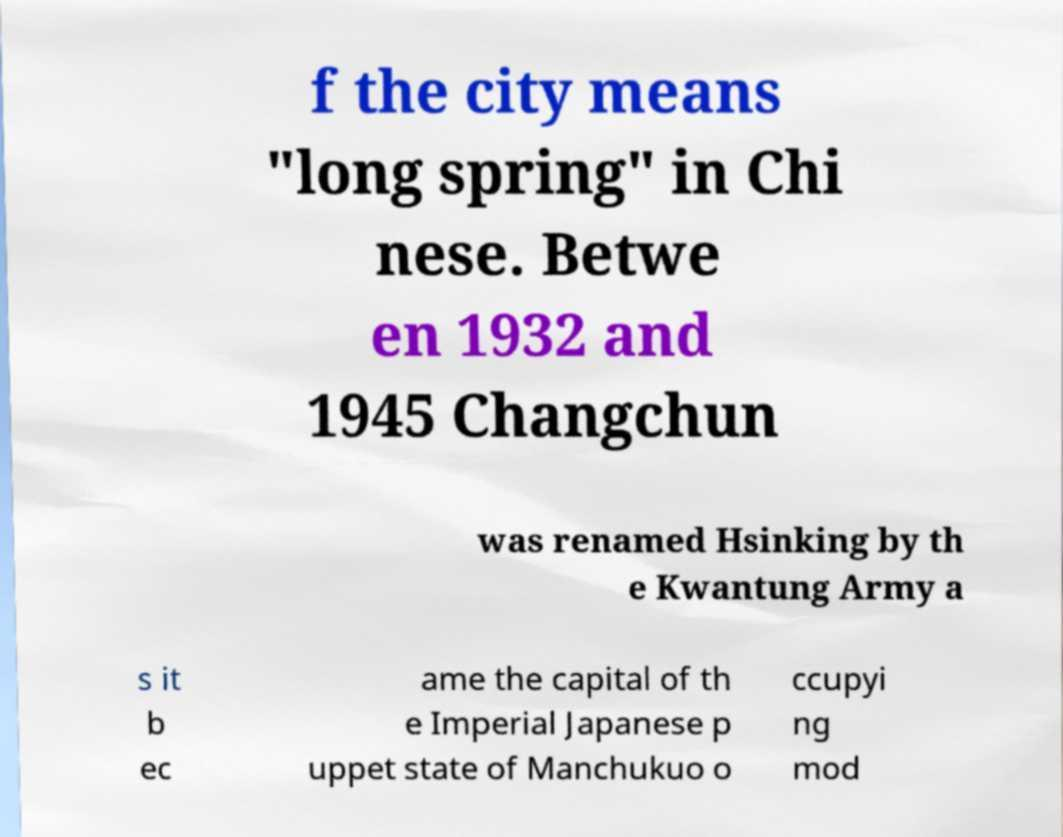Can you accurately transcribe the text from the provided image for me? f the city means "long spring" in Chi nese. Betwe en 1932 and 1945 Changchun was renamed Hsinking by th e Kwantung Army a s it b ec ame the capital of th e Imperial Japanese p uppet state of Manchukuo o ccupyi ng mod 